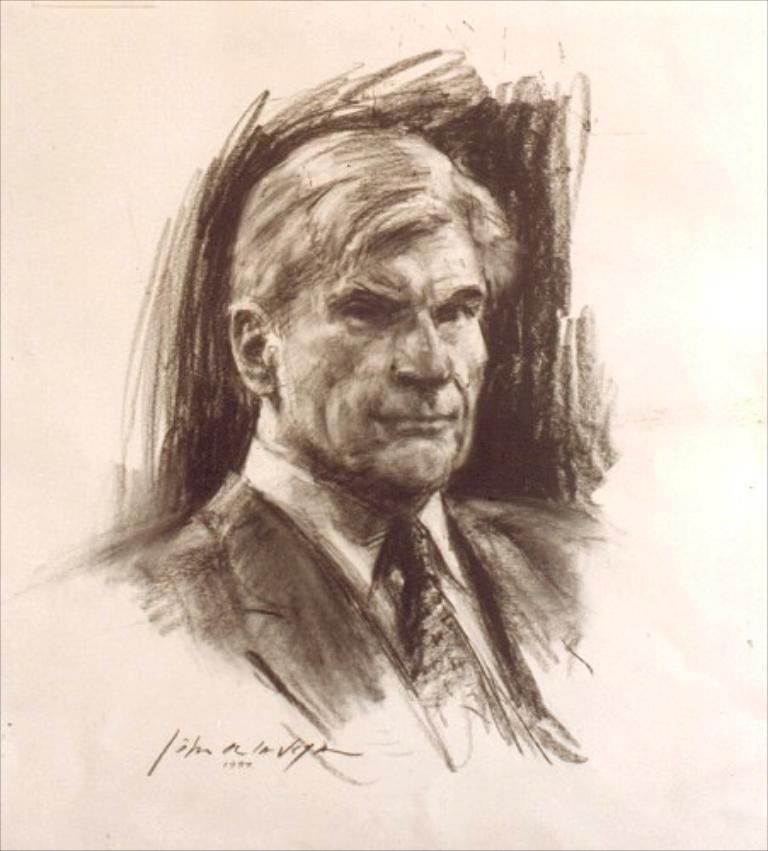What is the main subject of the image? The main subject of the image is a sketch. What does the sketch depict? The sketch depicts a man. Is there any text associated with the sketch? Yes, there is text at the bottom of the sketch. How many pears are being thrown away in the image? There are no pears or any indication of waste present in the image; it features a sketch of a man with text at the bottom. 